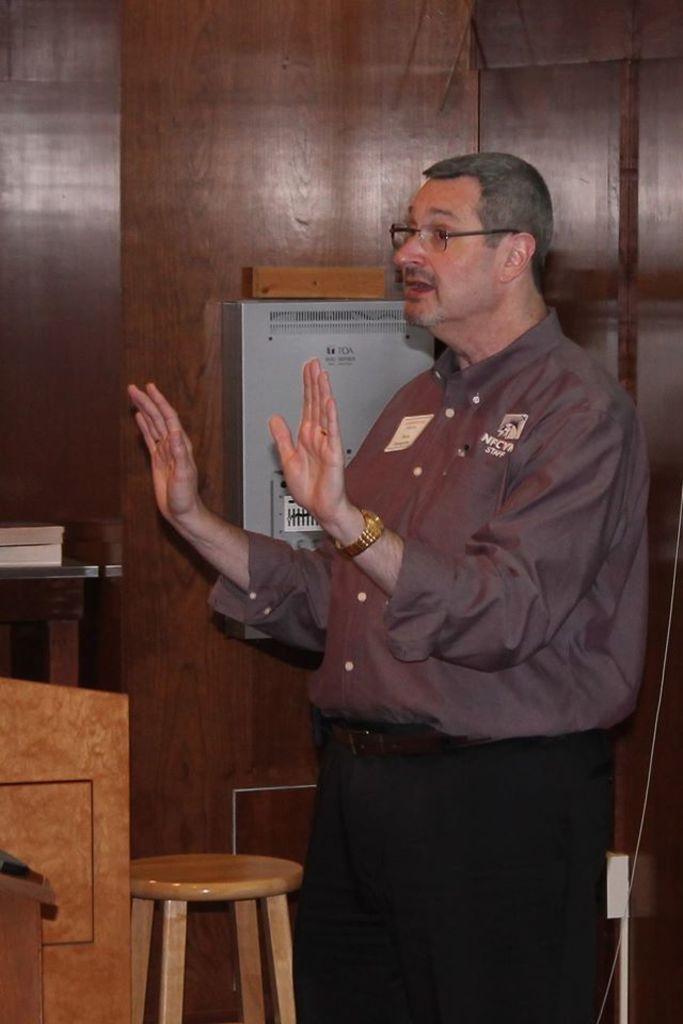In one or two sentences, can you explain what this image depicts? in this image there is a man standing and explaining about something and at back ground there is chair , table , book and a box. 